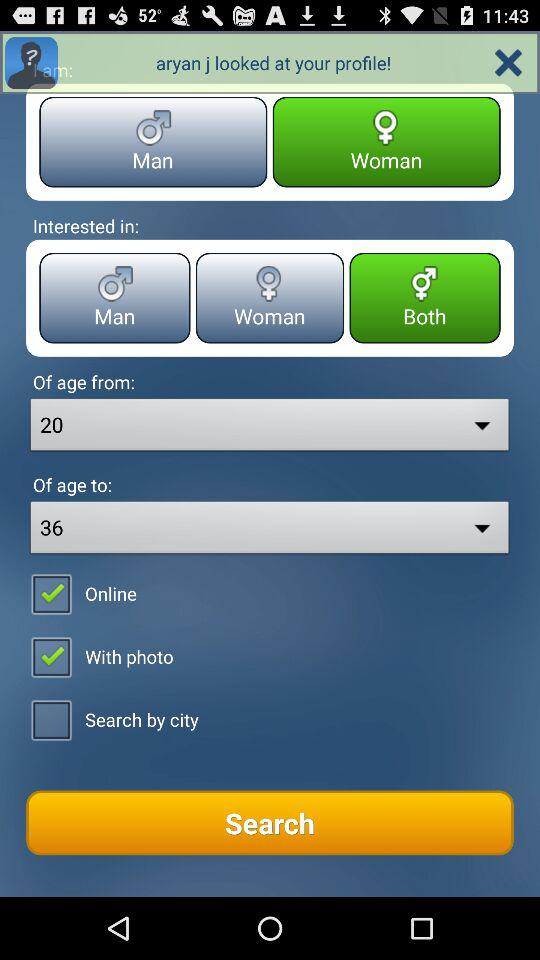In which drop-down box is option 36 selected? The option 36 is selected in the "Of age to" drop-down box. 